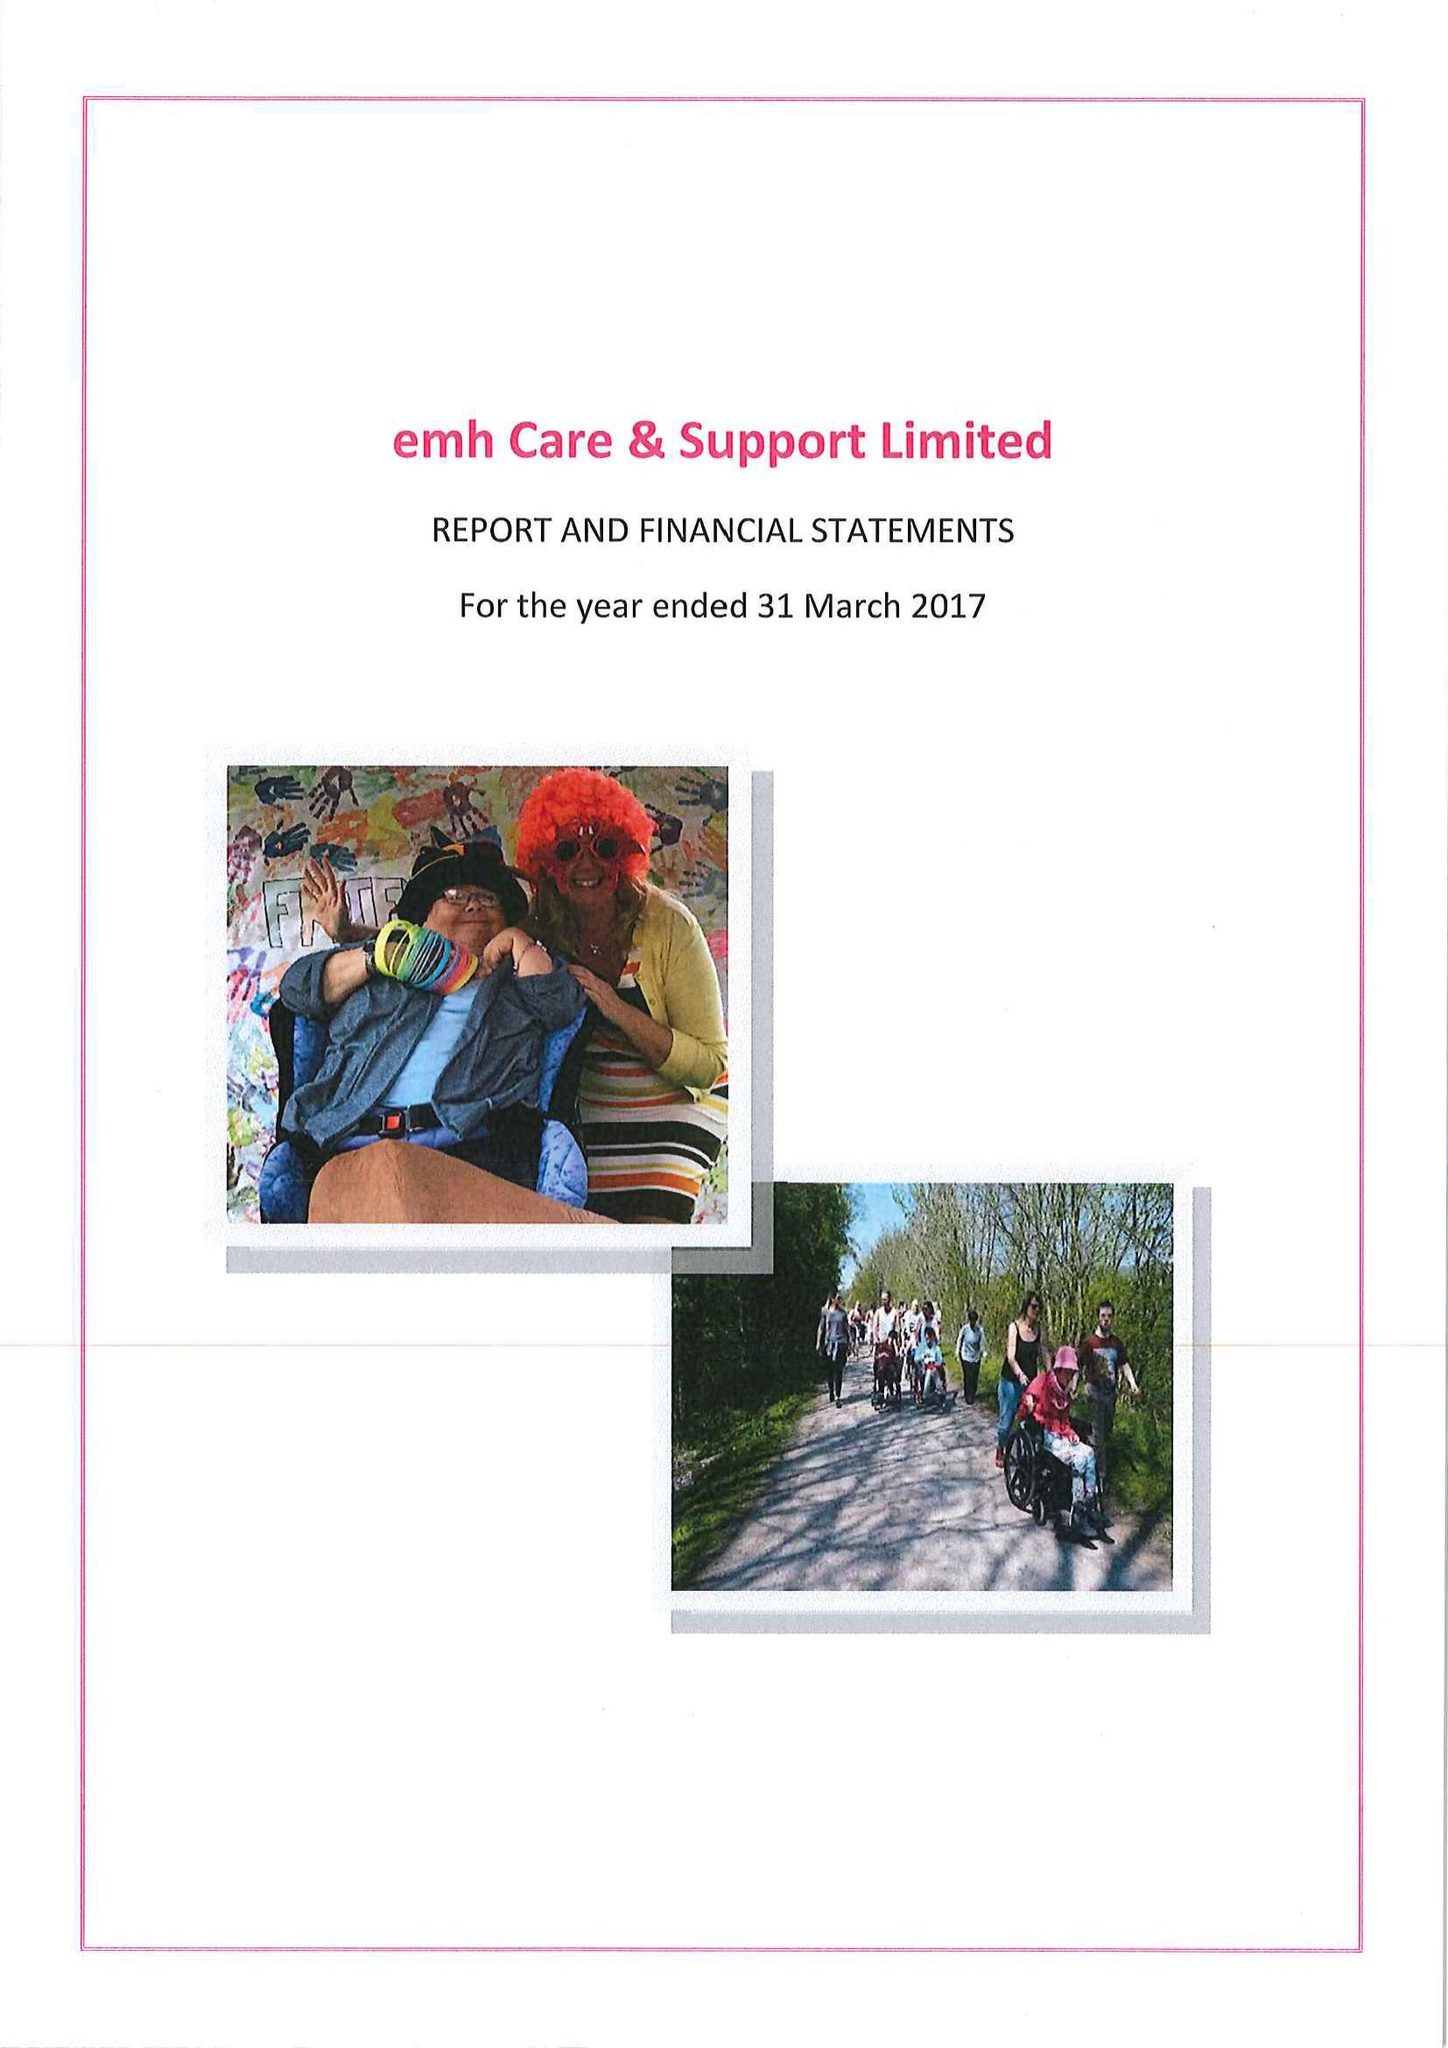What is the value for the address__postcode?
Answer the question using a single word or phrase. LE67 4JP 